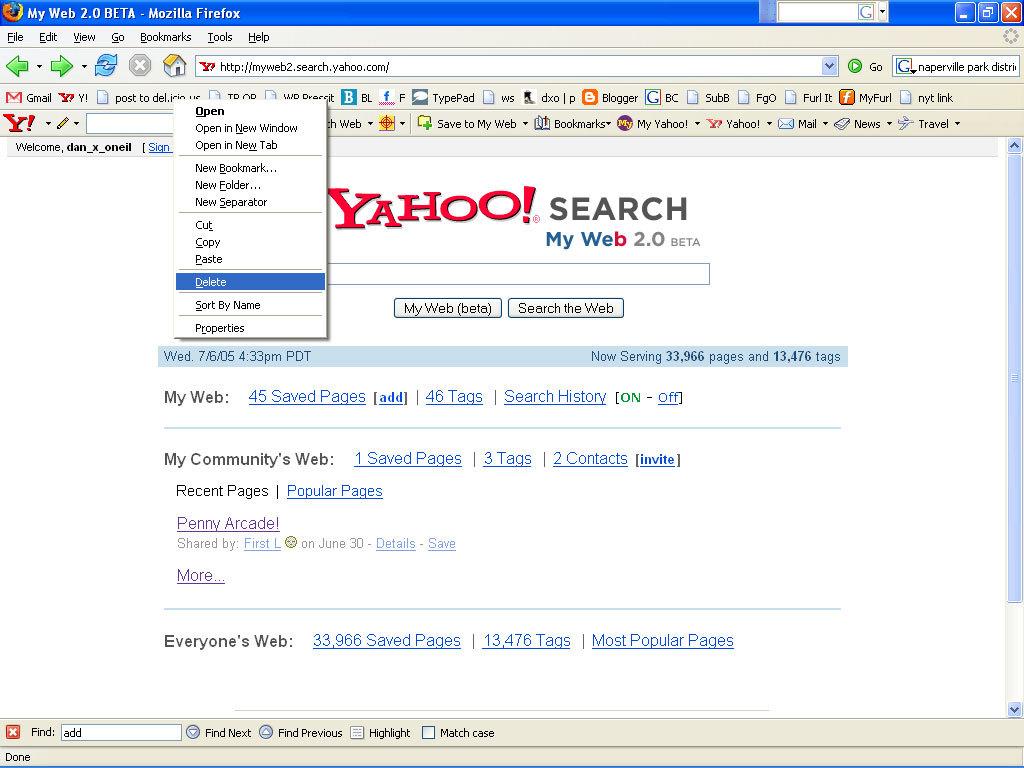What search engine is this?
Keep it short and to the point. Yahoo. How many pages?
Your answer should be very brief. 33,966. 